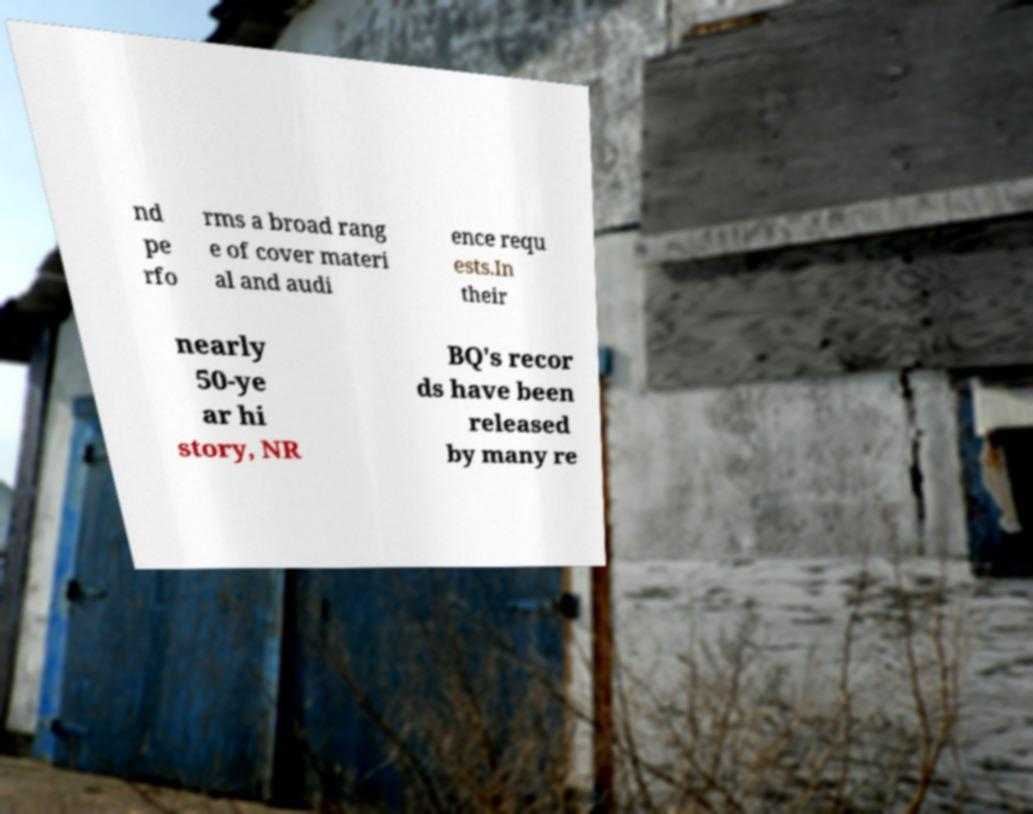I need the written content from this picture converted into text. Can you do that? nd pe rfo rms a broad rang e of cover materi al and audi ence requ ests.In their nearly 50-ye ar hi story, NR BQ's recor ds have been released by many re 